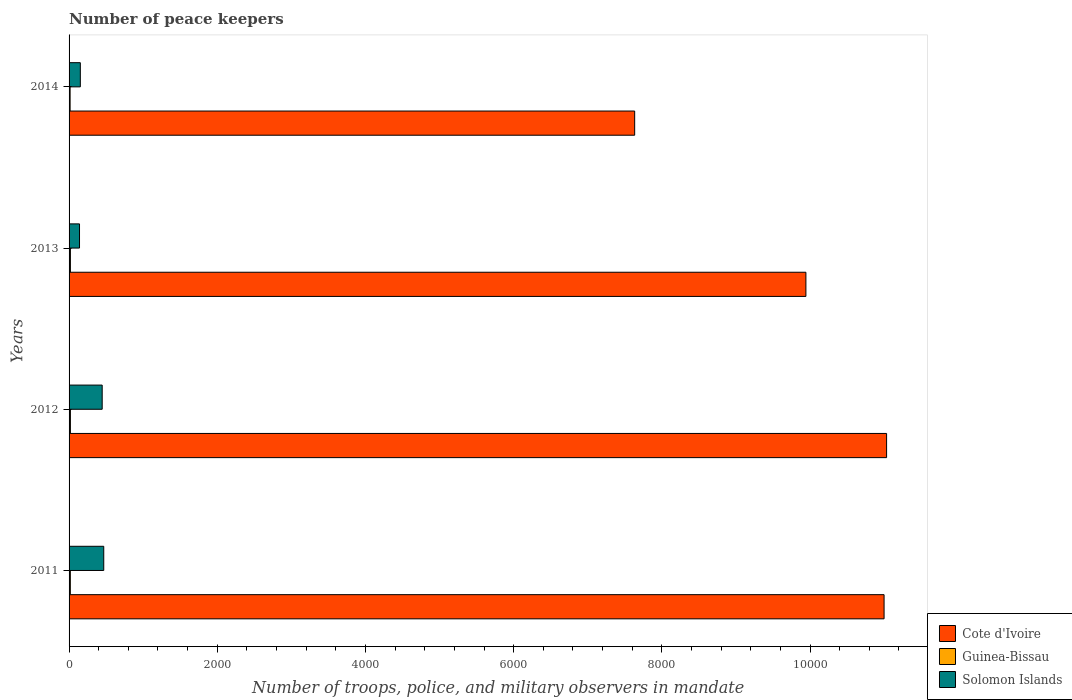How many different coloured bars are there?
Provide a short and direct response. 3. How many groups of bars are there?
Your answer should be very brief. 4. Are the number of bars per tick equal to the number of legend labels?
Offer a very short reply. Yes. Are the number of bars on each tick of the Y-axis equal?
Ensure brevity in your answer.  Yes. How many bars are there on the 2nd tick from the bottom?
Your answer should be very brief. 3. In how many cases, is the number of bars for a given year not equal to the number of legend labels?
Your answer should be compact. 0. What is the number of peace keepers in in Solomon Islands in 2012?
Your response must be concise. 447. Across all years, what is the maximum number of peace keepers in in Cote d'Ivoire?
Give a very brief answer. 1.10e+04. Across all years, what is the minimum number of peace keepers in in Solomon Islands?
Your answer should be compact. 141. In which year was the number of peace keepers in in Guinea-Bissau minimum?
Offer a terse response. 2014. What is the total number of peace keepers in in Solomon Islands in the graph?
Provide a short and direct response. 1208. What is the difference between the number of peace keepers in in Solomon Islands in 2013 and that in 2014?
Make the answer very short. -11. What is the difference between the number of peace keepers in in Guinea-Bissau in 2011 and the number of peace keepers in in Cote d'Ivoire in 2013?
Offer a very short reply. -9927. What is the average number of peace keepers in in Solomon Islands per year?
Give a very brief answer. 302. In the year 2011, what is the difference between the number of peace keepers in in Guinea-Bissau and number of peace keepers in in Cote d'Ivoire?
Give a very brief answer. -1.10e+04. What is the ratio of the number of peace keepers in in Guinea-Bissau in 2011 to that in 2014?
Offer a very short reply. 1.21. Is the number of peace keepers in in Guinea-Bissau in 2011 less than that in 2013?
Offer a very short reply. Yes. Is the difference between the number of peace keepers in in Guinea-Bissau in 2011 and 2012 greater than the difference between the number of peace keepers in in Cote d'Ivoire in 2011 and 2012?
Provide a short and direct response. Yes. What is the difference between the highest and the lowest number of peace keepers in in Solomon Islands?
Provide a short and direct response. 327. In how many years, is the number of peace keepers in in Solomon Islands greater than the average number of peace keepers in in Solomon Islands taken over all years?
Provide a succinct answer. 2. What does the 2nd bar from the top in 2012 represents?
Give a very brief answer. Guinea-Bissau. What does the 2nd bar from the bottom in 2014 represents?
Your response must be concise. Guinea-Bissau. How many bars are there?
Your response must be concise. 12. How many years are there in the graph?
Your response must be concise. 4. What is the difference between two consecutive major ticks on the X-axis?
Provide a succinct answer. 2000. Are the values on the major ticks of X-axis written in scientific E-notation?
Provide a succinct answer. No. Does the graph contain grids?
Give a very brief answer. No. How are the legend labels stacked?
Make the answer very short. Vertical. What is the title of the graph?
Ensure brevity in your answer.  Number of peace keepers. Does "Euro area" appear as one of the legend labels in the graph?
Your answer should be compact. No. What is the label or title of the X-axis?
Offer a very short reply. Number of troops, police, and military observers in mandate. What is the Number of troops, police, and military observers in mandate of Cote d'Ivoire in 2011?
Keep it short and to the point. 1.10e+04. What is the Number of troops, police, and military observers in mandate in Solomon Islands in 2011?
Your answer should be very brief. 468. What is the Number of troops, police, and military observers in mandate of Cote d'Ivoire in 2012?
Ensure brevity in your answer.  1.10e+04. What is the Number of troops, police, and military observers in mandate in Solomon Islands in 2012?
Your answer should be very brief. 447. What is the Number of troops, police, and military observers in mandate in Cote d'Ivoire in 2013?
Make the answer very short. 9944. What is the Number of troops, police, and military observers in mandate in Solomon Islands in 2013?
Offer a very short reply. 141. What is the Number of troops, police, and military observers in mandate in Cote d'Ivoire in 2014?
Offer a terse response. 7633. What is the Number of troops, police, and military observers in mandate in Guinea-Bissau in 2014?
Provide a succinct answer. 14. What is the Number of troops, police, and military observers in mandate of Solomon Islands in 2014?
Offer a very short reply. 152. Across all years, what is the maximum Number of troops, police, and military observers in mandate in Cote d'Ivoire?
Your response must be concise. 1.10e+04. Across all years, what is the maximum Number of troops, police, and military observers in mandate in Guinea-Bissau?
Offer a terse response. 18. Across all years, what is the maximum Number of troops, police, and military observers in mandate in Solomon Islands?
Give a very brief answer. 468. Across all years, what is the minimum Number of troops, police, and military observers in mandate of Cote d'Ivoire?
Keep it short and to the point. 7633. Across all years, what is the minimum Number of troops, police, and military observers in mandate in Guinea-Bissau?
Provide a short and direct response. 14. Across all years, what is the minimum Number of troops, police, and military observers in mandate of Solomon Islands?
Your answer should be compact. 141. What is the total Number of troops, police, and military observers in mandate of Cote d'Ivoire in the graph?
Your answer should be compact. 3.96e+04. What is the total Number of troops, police, and military observers in mandate in Solomon Islands in the graph?
Offer a terse response. 1208. What is the difference between the Number of troops, police, and military observers in mandate in Cote d'Ivoire in 2011 and that in 2012?
Keep it short and to the point. -34. What is the difference between the Number of troops, police, and military observers in mandate in Guinea-Bissau in 2011 and that in 2012?
Your answer should be very brief. -1. What is the difference between the Number of troops, police, and military observers in mandate in Solomon Islands in 2011 and that in 2012?
Offer a very short reply. 21. What is the difference between the Number of troops, police, and military observers in mandate of Cote d'Ivoire in 2011 and that in 2013?
Offer a terse response. 1055. What is the difference between the Number of troops, police, and military observers in mandate in Guinea-Bissau in 2011 and that in 2013?
Offer a terse response. -1. What is the difference between the Number of troops, police, and military observers in mandate of Solomon Islands in 2011 and that in 2013?
Your response must be concise. 327. What is the difference between the Number of troops, police, and military observers in mandate of Cote d'Ivoire in 2011 and that in 2014?
Your response must be concise. 3366. What is the difference between the Number of troops, police, and military observers in mandate of Solomon Islands in 2011 and that in 2014?
Your response must be concise. 316. What is the difference between the Number of troops, police, and military observers in mandate of Cote d'Ivoire in 2012 and that in 2013?
Your response must be concise. 1089. What is the difference between the Number of troops, police, and military observers in mandate in Solomon Islands in 2012 and that in 2013?
Provide a succinct answer. 306. What is the difference between the Number of troops, police, and military observers in mandate of Cote d'Ivoire in 2012 and that in 2014?
Offer a very short reply. 3400. What is the difference between the Number of troops, police, and military observers in mandate in Solomon Islands in 2012 and that in 2014?
Ensure brevity in your answer.  295. What is the difference between the Number of troops, police, and military observers in mandate of Cote d'Ivoire in 2013 and that in 2014?
Your answer should be very brief. 2311. What is the difference between the Number of troops, police, and military observers in mandate in Cote d'Ivoire in 2011 and the Number of troops, police, and military observers in mandate in Guinea-Bissau in 2012?
Make the answer very short. 1.10e+04. What is the difference between the Number of troops, police, and military observers in mandate in Cote d'Ivoire in 2011 and the Number of troops, police, and military observers in mandate in Solomon Islands in 2012?
Your answer should be very brief. 1.06e+04. What is the difference between the Number of troops, police, and military observers in mandate of Guinea-Bissau in 2011 and the Number of troops, police, and military observers in mandate of Solomon Islands in 2012?
Offer a very short reply. -430. What is the difference between the Number of troops, police, and military observers in mandate of Cote d'Ivoire in 2011 and the Number of troops, police, and military observers in mandate of Guinea-Bissau in 2013?
Provide a succinct answer. 1.10e+04. What is the difference between the Number of troops, police, and military observers in mandate in Cote d'Ivoire in 2011 and the Number of troops, police, and military observers in mandate in Solomon Islands in 2013?
Ensure brevity in your answer.  1.09e+04. What is the difference between the Number of troops, police, and military observers in mandate in Guinea-Bissau in 2011 and the Number of troops, police, and military observers in mandate in Solomon Islands in 2013?
Offer a very short reply. -124. What is the difference between the Number of troops, police, and military observers in mandate in Cote d'Ivoire in 2011 and the Number of troops, police, and military observers in mandate in Guinea-Bissau in 2014?
Make the answer very short. 1.10e+04. What is the difference between the Number of troops, police, and military observers in mandate of Cote d'Ivoire in 2011 and the Number of troops, police, and military observers in mandate of Solomon Islands in 2014?
Give a very brief answer. 1.08e+04. What is the difference between the Number of troops, police, and military observers in mandate of Guinea-Bissau in 2011 and the Number of troops, police, and military observers in mandate of Solomon Islands in 2014?
Your response must be concise. -135. What is the difference between the Number of troops, police, and military observers in mandate in Cote d'Ivoire in 2012 and the Number of troops, police, and military observers in mandate in Guinea-Bissau in 2013?
Your answer should be very brief. 1.10e+04. What is the difference between the Number of troops, police, and military observers in mandate in Cote d'Ivoire in 2012 and the Number of troops, police, and military observers in mandate in Solomon Islands in 2013?
Offer a terse response. 1.09e+04. What is the difference between the Number of troops, police, and military observers in mandate in Guinea-Bissau in 2012 and the Number of troops, police, and military observers in mandate in Solomon Islands in 2013?
Ensure brevity in your answer.  -123. What is the difference between the Number of troops, police, and military observers in mandate of Cote d'Ivoire in 2012 and the Number of troops, police, and military observers in mandate of Guinea-Bissau in 2014?
Make the answer very short. 1.10e+04. What is the difference between the Number of troops, police, and military observers in mandate of Cote d'Ivoire in 2012 and the Number of troops, police, and military observers in mandate of Solomon Islands in 2014?
Keep it short and to the point. 1.09e+04. What is the difference between the Number of troops, police, and military observers in mandate of Guinea-Bissau in 2012 and the Number of troops, police, and military observers in mandate of Solomon Islands in 2014?
Your answer should be very brief. -134. What is the difference between the Number of troops, police, and military observers in mandate of Cote d'Ivoire in 2013 and the Number of troops, police, and military observers in mandate of Guinea-Bissau in 2014?
Your response must be concise. 9930. What is the difference between the Number of troops, police, and military observers in mandate of Cote d'Ivoire in 2013 and the Number of troops, police, and military observers in mandate of Solomon Islands in 2014?
Provide a short and direct response. 9792. What is the difference between the Number of troops, police, and military observers in mandate of Guinea-Bissau in 2013 and the Number of troops, police, and military observers in mandate of Solomon Islands in 2014?
Ensure brevity in your answer.  -134. What is the average Number of troops, police, and military observers in mandate in Cote d'Ivoire per year?
Make the answer very short. 9902.25. What is the average Number of troops, police, and military observers in mandate in Guinea-Bissau per year?
Offer a very short reply. 16.75. What is the average Number of troops, police, and military observers in mandate in Solomon Islands per year?
Ensure brevity in your answer.  302. In the year 2011, what is the difference between the Number of troops, police, and military observers in mandate in Cote d'Ivoire and Number of troops, police, and military observers in mandate in Guinea-Bissau?
Your answer should be compact. 1.10e+04. In the year 2011, what is the difference between the Number of troops, police, and military observers in mandate in Cote d'Ivoire and Number of troops, police, and military observers in mandate in Solomon Islands?
Ensure brevity in your answer.  1.05e+04. In the year 2011, what is the difference between the Number of troops, police, and military observers in mandate in Guinea-Bissau and Number of troops, police, and military observers in mandate in Solomon Islands?
Offer a very short reply. -451. In the year 2012, what is the difference between the Number of troops, police, and military observers in mandate of Cote d'Ivoire and Number of troops, police, and military observers in mandate of Guinea-Bissau?
Ensure brevity in your answer.  1.10e+04. In the year 2012, what is the difference between the Number of troops, police, and military observers in mandate in Cote d'Ivoire and Number of troops, police, and military observers in mandate in Solomon Islands?
Ensure brevity in your answer.  1.06e+04. In the year 2012, what is the difference between the Number of troops, police, and military observers in mandate in Guinea-Bissau and Number of troops, police, and military observers in mandate in Solomon Islands?
Ensure brevity in your answer.  -429. In the year 2013, what is the difference between the Number of troops, police, and military observers in mandate in Cote d'Ivoire and Number of troops, police, and military observers in mandate in Guinea-Bissau?
Provide a succinct answer. 9926. In the year 2013, what is the difference between the Number of troops, police, and military observers in mandate in Cote d'Ivoire and Number of troops, police, and military observers in mandate in Solomon Islands?
Provide a short and direct response. 9803. In the year 2013, what is the difference between the Number of troops, police, and military observers in mandate in Guinea-Bissau and Number of troops, police, and military observers in mandate in Solomon Islands?
Offer a very short reply. -123. In the year 2014, what is the difference between the Number of troops, police, and military observers in mandate of Cote d'Ivoire and Number of troops, police, and military observers in mandate of Guinea-Bissau?
Keep it short and to the point. 7619. In the year 2014, what is the difference between the Number of troops, police, and military observers in mandate in Cote d'Ivoire and Number of troops, police, and military observers in mandate in Solomon Islands?
Your answer should be very brief. 7481. In the year 2014, what is the difference between the Number of troops, police, and military observers in mandate in Guinea-Bissau and Number of troops, police, and military observers in mandate in Solomon Islands?
Make the answer very short. -138. What is the ratio of the Number of troops, police, and military observers in mandate in Cote d'Ivoire in 2011 to that in 2012?
Ensure brevity in your answer.  1. What is the ratio of the Number of troops, police, and military observers in mandate of Solomon Islands in 2011 to that in 2012?
Offer a terse response. 1.05. What is the ratio of the Number of troops, police, and military observers in mandate in Cote d'Ivoire in 2011 to that in 2013?
Offer a terse response. 1.11. What is the ratio of the Number of troops, police, and military observers in mandate of Guinea-Bissau in 2011 to that in 2013?
Your response must be concise. 0.94. What is the ratio of the Number of troops, police, and military observers in mandate of Solomon Islands in 2011 to that in 2013?
Your answer should be compact. 3.32. What is the ratio of the Number of troops, police, and military observers in mandate in Cote d'Ivoire in 2011 to that in 2014?
Provide a short and direct response. 1.44. What is the ratio of the Number of troops, police, and military observers in mandate of Guinea-Bissau in 2011 to that in 2014?
Offer a terse response. 1.21. What is the ratio of the Number of troops, police, and military observers in mandate in Solomon Islands in 2011 to that in 2014?
Provide a succinct answer. 3.08. What is the ratio of the Number of troops, police, and military observers in mandate of Cote d'Ivoire in 2012 to that in 2013?
Ensure brevity in your answer.  1.11. What is the ratio of the Number of troops, police, and military observers in mandate of Solomon Islands in 2012 to that in 2013?
Your answer should be very brief. 3.17. What is the ratio of the Number of troops, police, and military observers in mandate in Cote d'Ivoire in 2012 to that in 2014?
Ensure brevity in your answer.  1.45. What is the ratio of the Number of troops, police, and military observers in mandate in Guinea-Bissau in 2012 to that in 2014?
Provide a succinct answer. 1.29. What is the ratio of the Number of troops, police, and military observers in mandate of Solomon Islands in 2012 to that in 2014?
Make the answer very short. 2.94. What is the ratio of the Number of troops, police, and military observers in mandate of Cote d'Ivoire in 2013 to that in 2014?
Your answer should be very brief. 1.3. What is the ratio of the Number of troops, police, and military observers in mandate of Guinea-Bissau in 2013 to that in 2014?
Your answer should be very brief. 1.29. What is the ratio of the Number of troops, police, and military observers in mandate of Solomon Islands in 2013 to that in 2014?
Offer a very short reply. 0.93. What is the difference between the highest and the second highest Number of troops, police, and military observers in mandate of Cote d'Ivoire?
Make the answer very short. 34. What is the difference between the highest and the second highest Number of troops, police, and military observers in mandate in Guinea-Bissau?
Keep it short and to the point. 0. What is the difference between the highest and the second highest Number of troops, police, and military observers in mandate of Solomon Islands?
Offer a terse response. 21. What is the difference between the highest and the lowest Number of troops, police, and military observers in mandate in Cote d'Ivoire?
Provide a short and direct response. 3400. What is the difference between the highest and the lowest Number of troops, police, and military observers in mandate in Solomon Islands?
Keep it short and to the point. 327. 